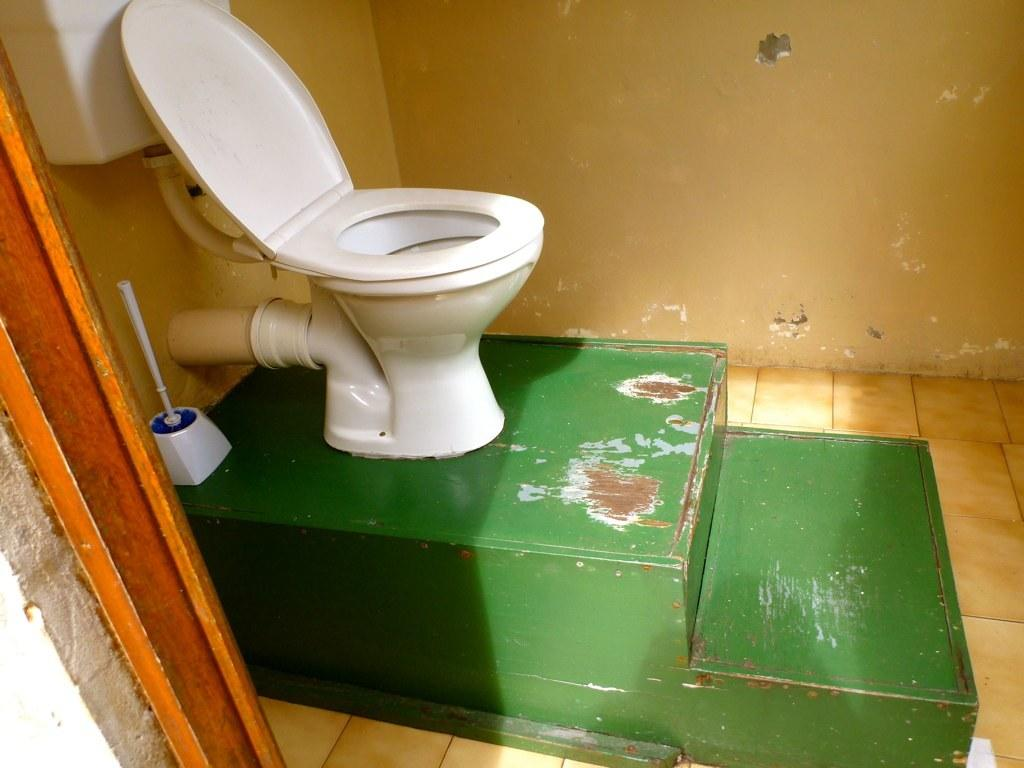What is the main structure in the image? There is a green platform in the image. What is located on the platform? A toilet seat and a flusher are present on the platform. What object can be used for cleaning in the image? There is a brush in the image. What type of vegetable is being chopped on the platform in the image? There is no vegetable or chopping activity present in the image; it features a toilet seat, flusher, and brush. How many sisters are visible in the image? There are no people, including sisters, present in the image. 